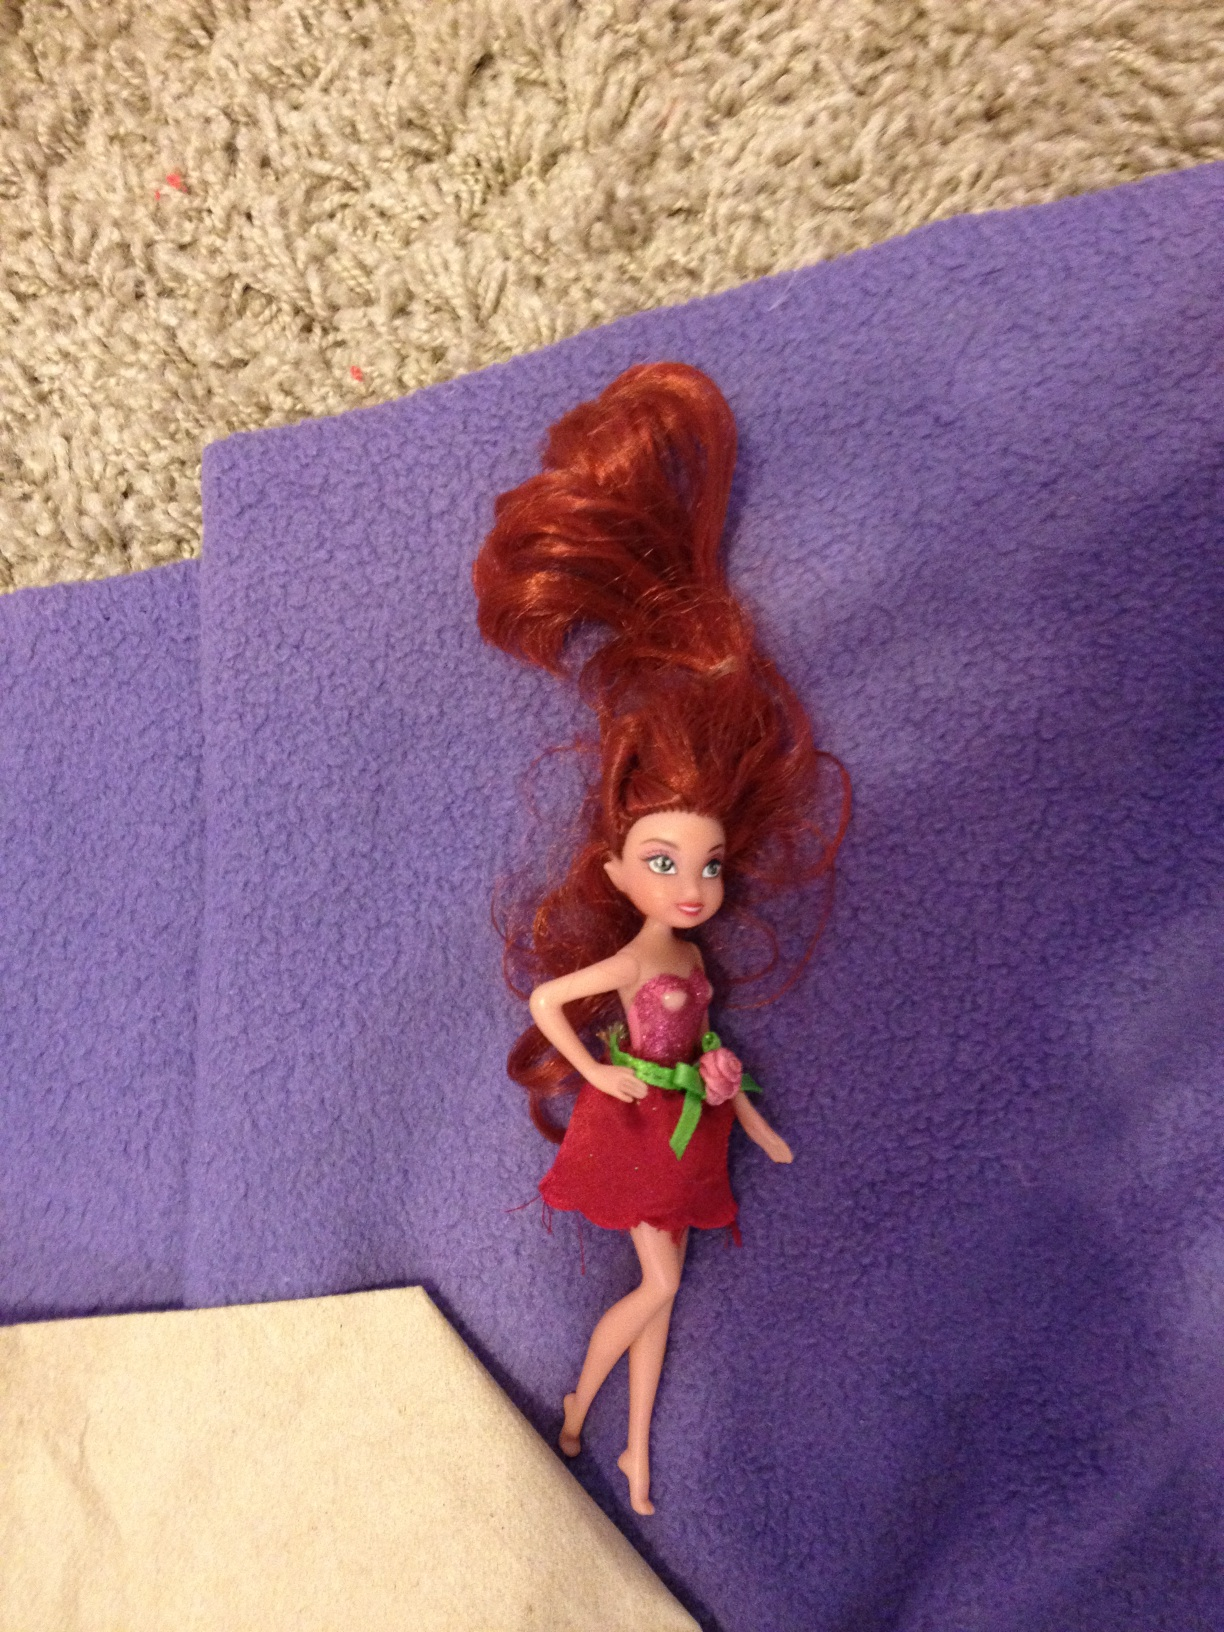What color is this? The dominant color in the image appears to be purple, which is the color of the surface on which the object is placed. The object itself, which seems to be a doll, features red as the main color of its garment. 